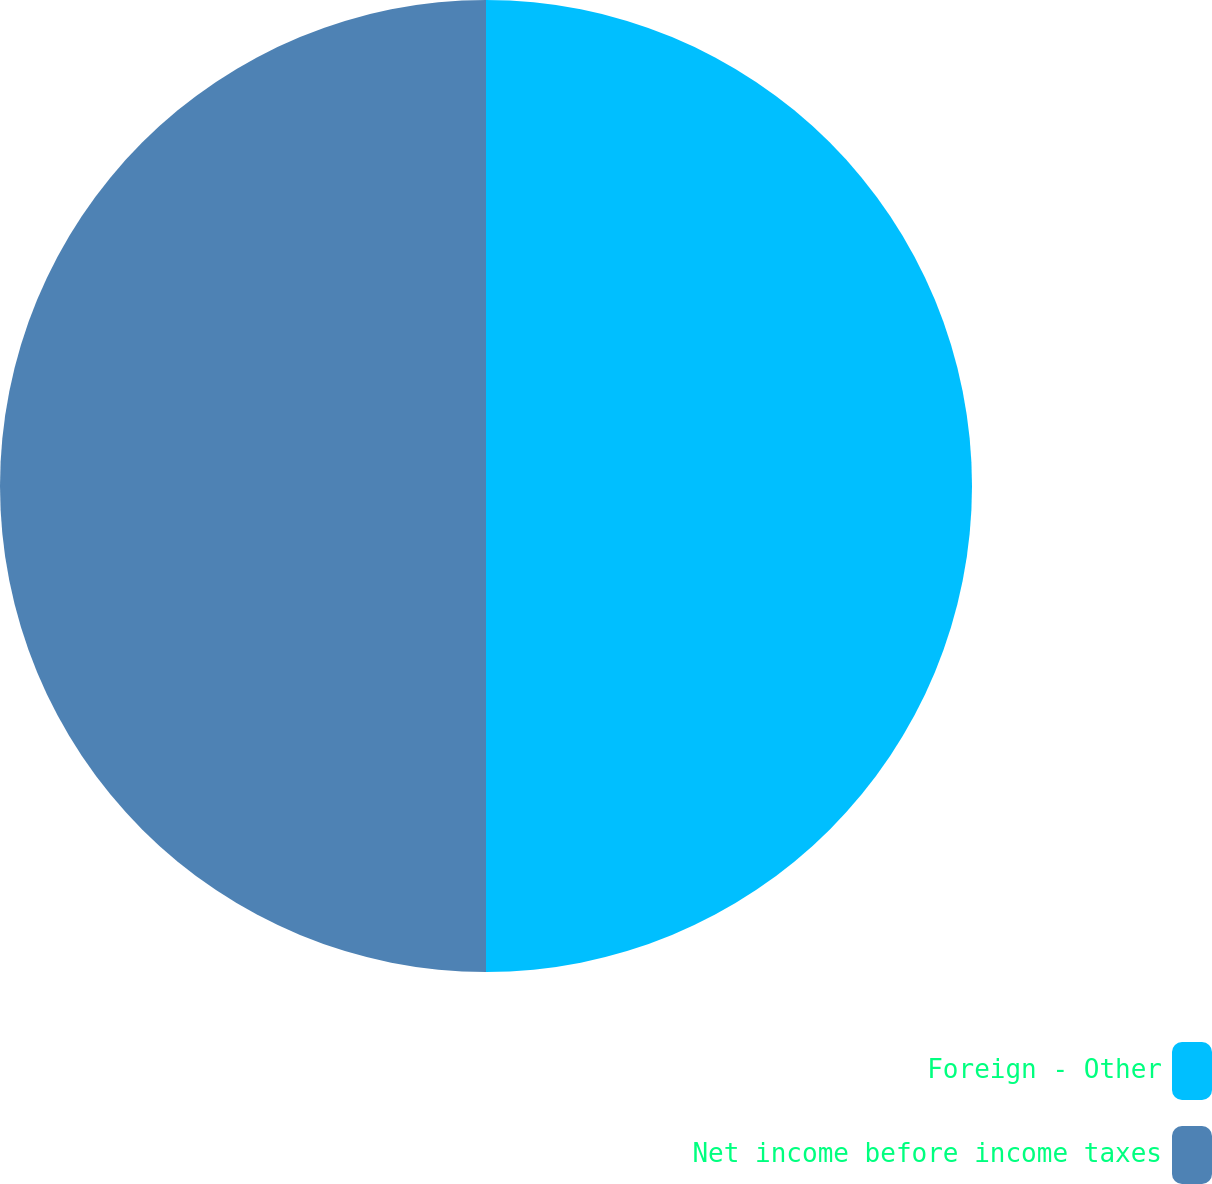Convert chart to OTSL. <chart><loc_0><loc_0><loc_500><loc_500><pie_chart><fcel>Foreign - Other<fcel>Net income before income taxes<nl><fcel>50.0%<fcel>50.0%<nl></chart> 